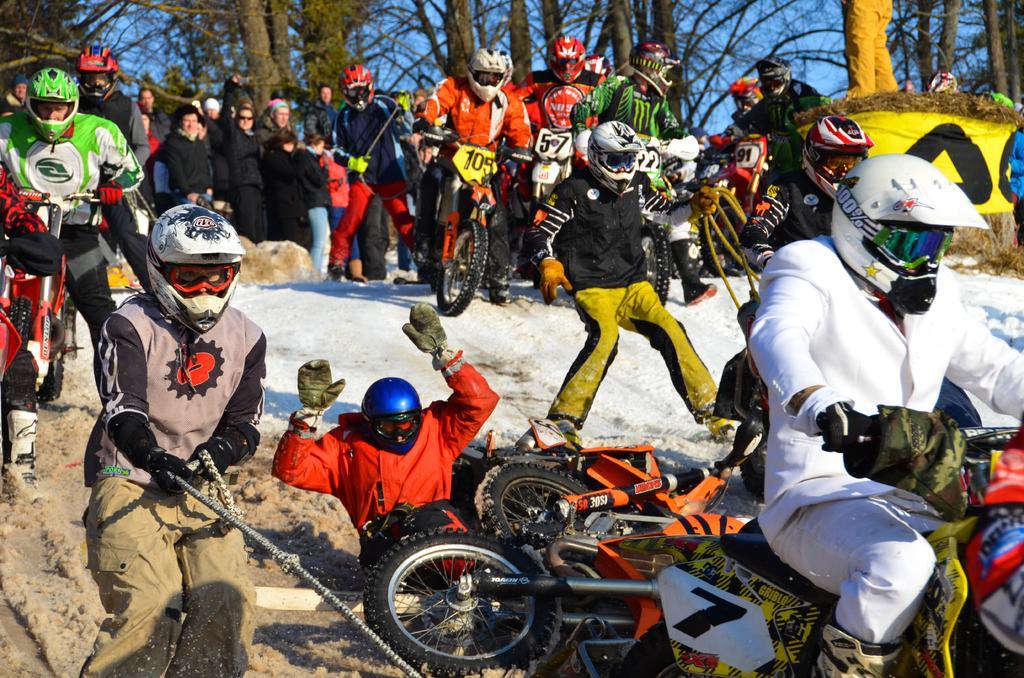How would you summarize this image in a sentence or two? In this image we can see some people preparing for the bike race. In the background we can see trees and some part of sky is also visible. 